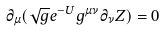Convert formula to latex. <formula><loc_0><loc_0><loc_500><loc_500>\partial _ { \mu } ( \sqrt { g } e ^ { - U } g ^ { \mu \nu } \partial _ { \nu } Z ) = 0</formula> 